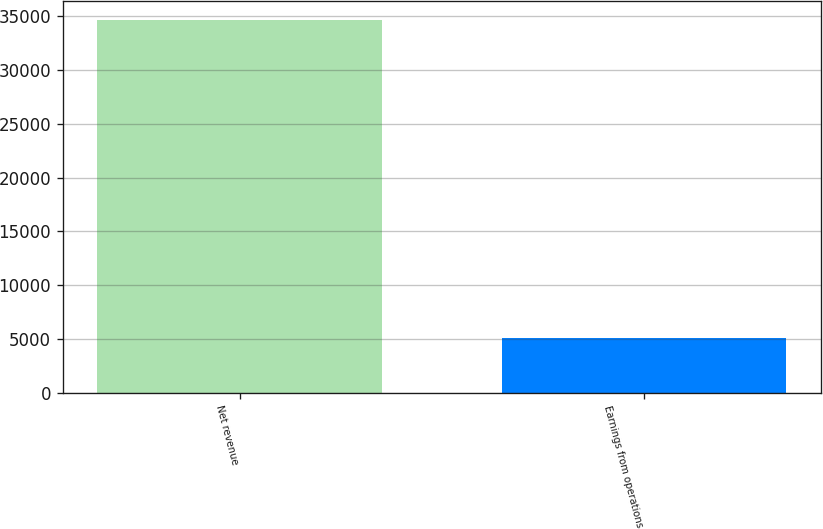Convert chart. <chart><loc_0><loc_0><loc_500><loc_500><bar_chart><fcel>Net revenue<fcel>Earnings from operations<nl><fcel>34693<fcel>5044<nl></chart> 